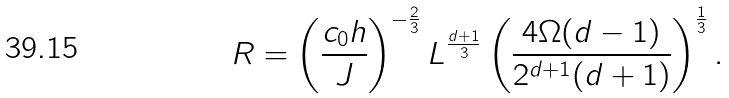<formula> <loc_0><loc_0><loc_500><loc_500>R = \left ( \frac { c _ { 0 } h } { J } \right ) ^ { - \frac { 2 } { 3 } } L ^ { \frac { d + 1 } { 3 } } \left ( \frac { 4 \Omega ( d - 1 ) } { 2 ^ { d + 1 } ( d + 1 ) } \right ) ^ { \frac { 1 } { 3 } } .</formula> 